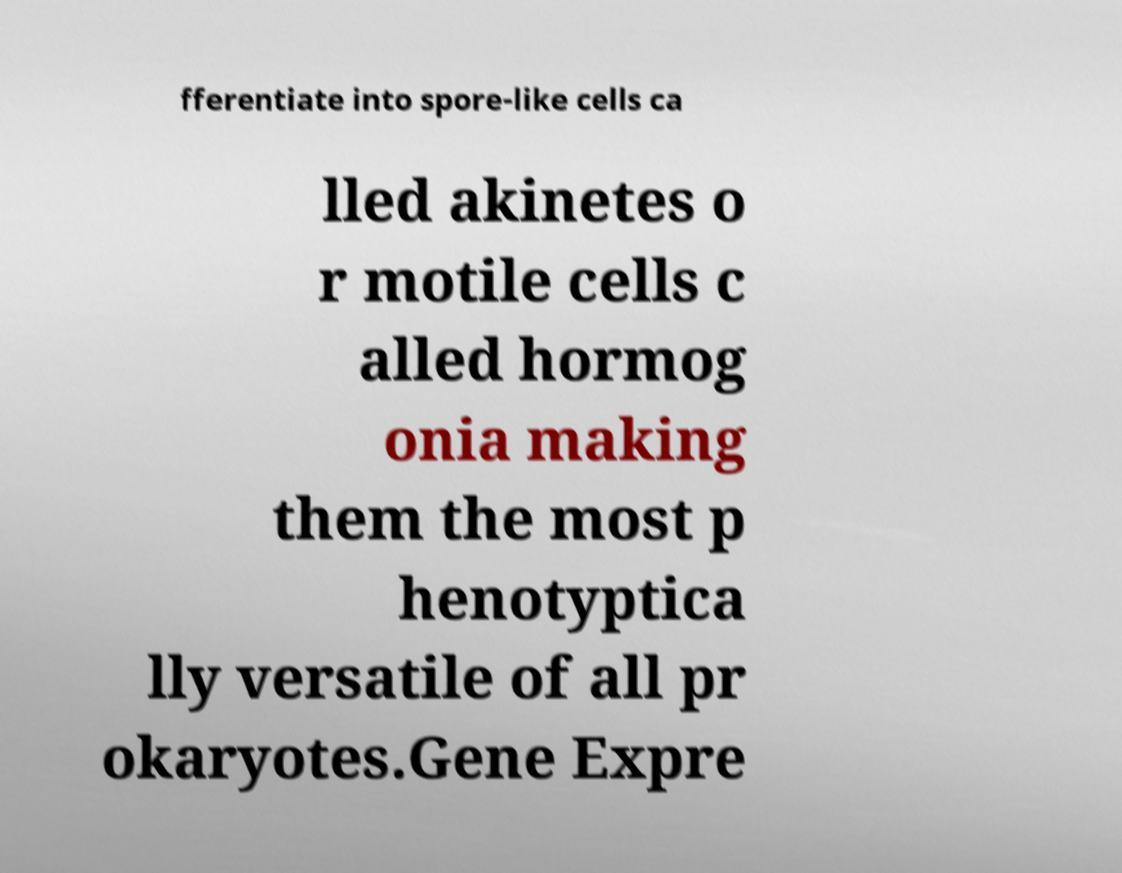Can you read and provide the text displayed in the image?This photo seems to have some interesting text. Can you extract and type it out for me? fferentiate into spore-like cells ca lled akinetes o r motile cells c alled hormog onia making them the most p henotyptica lly versatile of all pr okaryotes.Gene Expre 